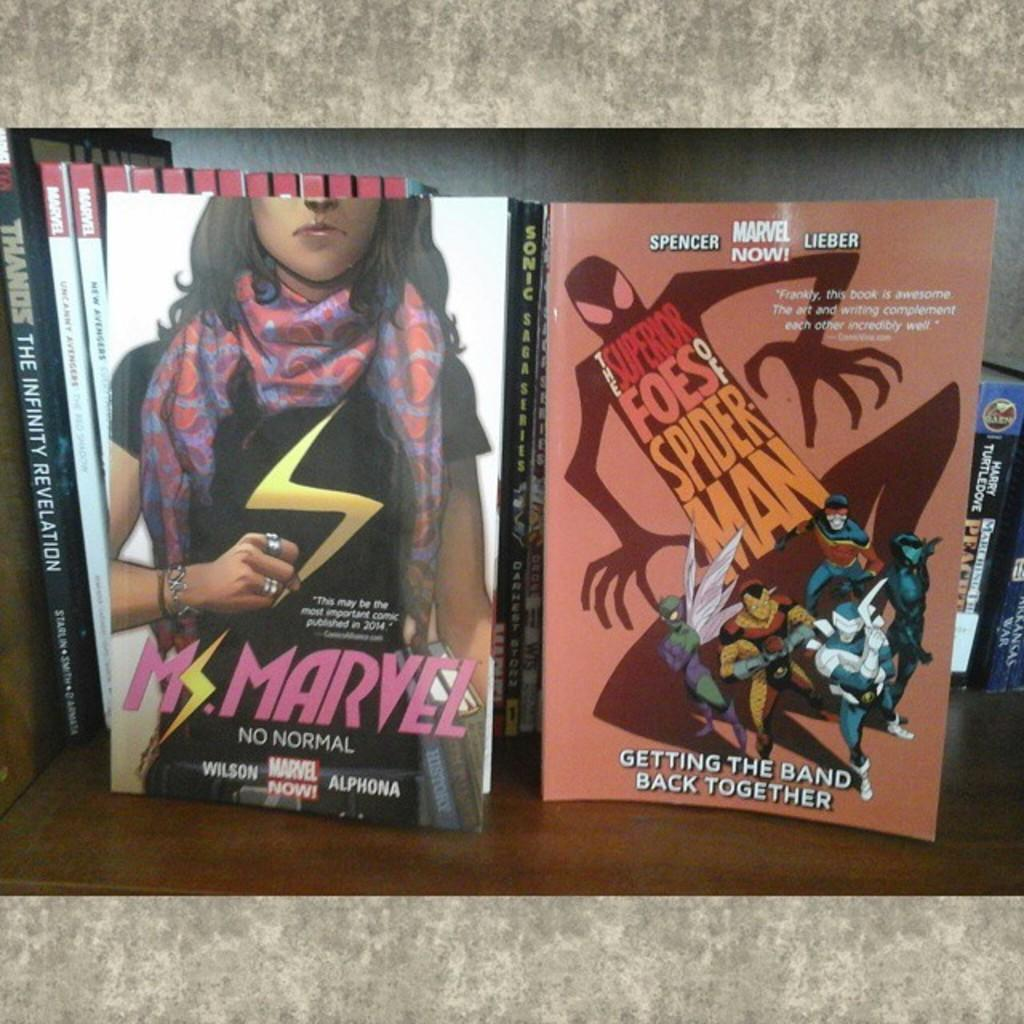<image>
Share a concise interpretation of the image provided. An advertisement for a Marvel movie next to another one 